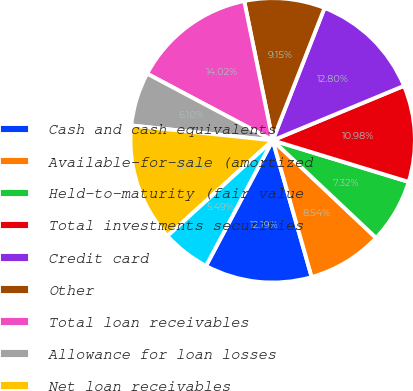Convert chart. <chart><loc_0><loc_0><loc_500><loc_500><pie_chart><fcel>Cash and cash equivalents<fcel>Available-for-sale (amortized<fcel>Held-to-maturity (fair value<fcel>Total investments securities<fcel>Credit card<fcel>Other<fcel>Total loan receivables<fcel>Allowance for loan losses<fcel>Net loan receivables<fcel>Amounts due from asset<nl><fcel>12.19%<fcel>8.54%<fcel>7.32%<fcel>10.98%<fcel>12.8%<fcel>9.15%<fcel>14.02%<fcel>6.1%<fcel>13.41%<fcel>5.49%<nl></chart> 